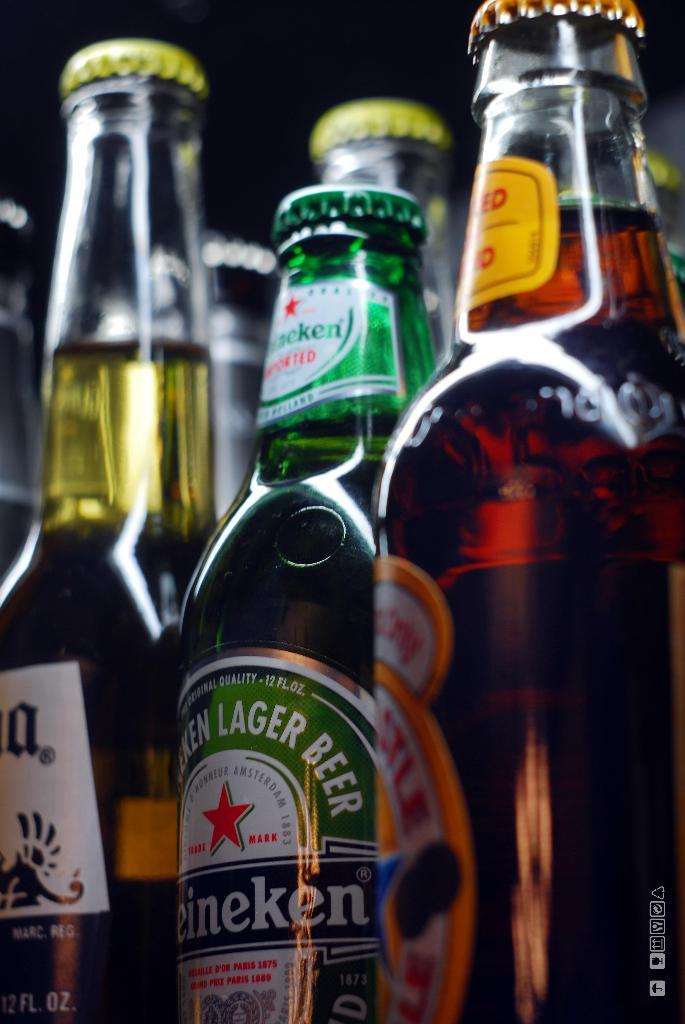<image>
Give a short and clear explanation of the subsequent image. A closeup of various beer bottles shows a Heineken bottle in the middle. 